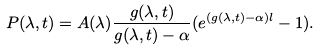Convert formula to latex. <formula><loc_0><loc_0><loc_500><loc_500>P ( \lambda , t ) = A ( \lambda ) \frac { g ( \lambda , t ) } { g ( \lambda , t ) - \alpha } ( e ^ { ( g ( \lambda , t ) - \alpha ) l } - 1 ) .</formula> 